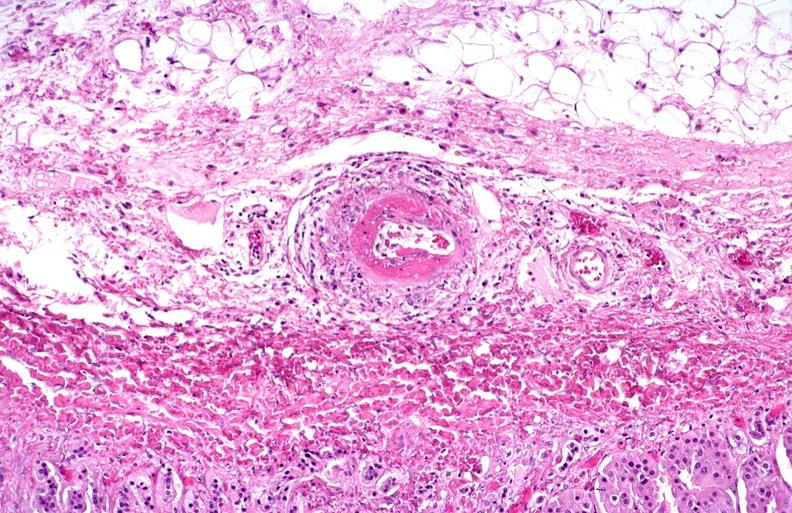what does this image show?
Answer the question using a single word or phrase. Polyarteritis nodosa 